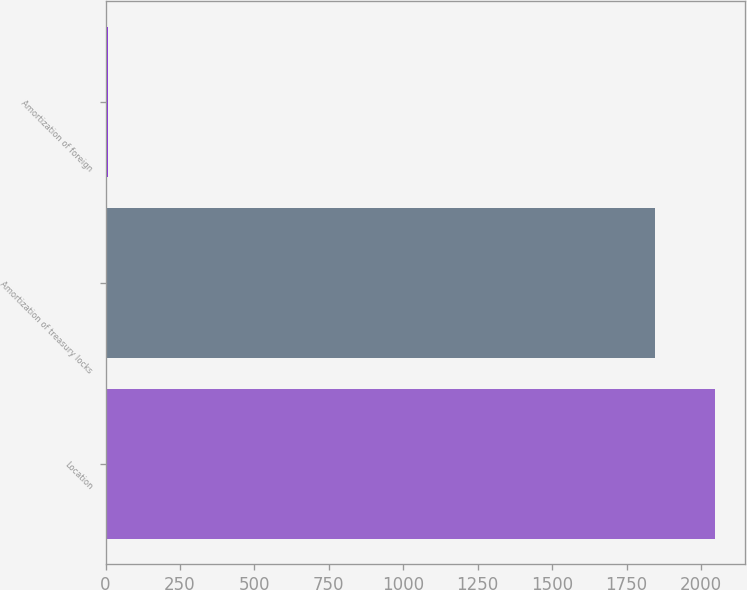Convert chart to OTSL. <chart><loc_0><loc_0><loc_500><loc_500><bar_chart><fcel>Location<fcel>Amortization of treasury locks<fcel>Amortization of foreign<nl><fcel>2046.4<fcel>1846<fcel>7<nl></chart> 